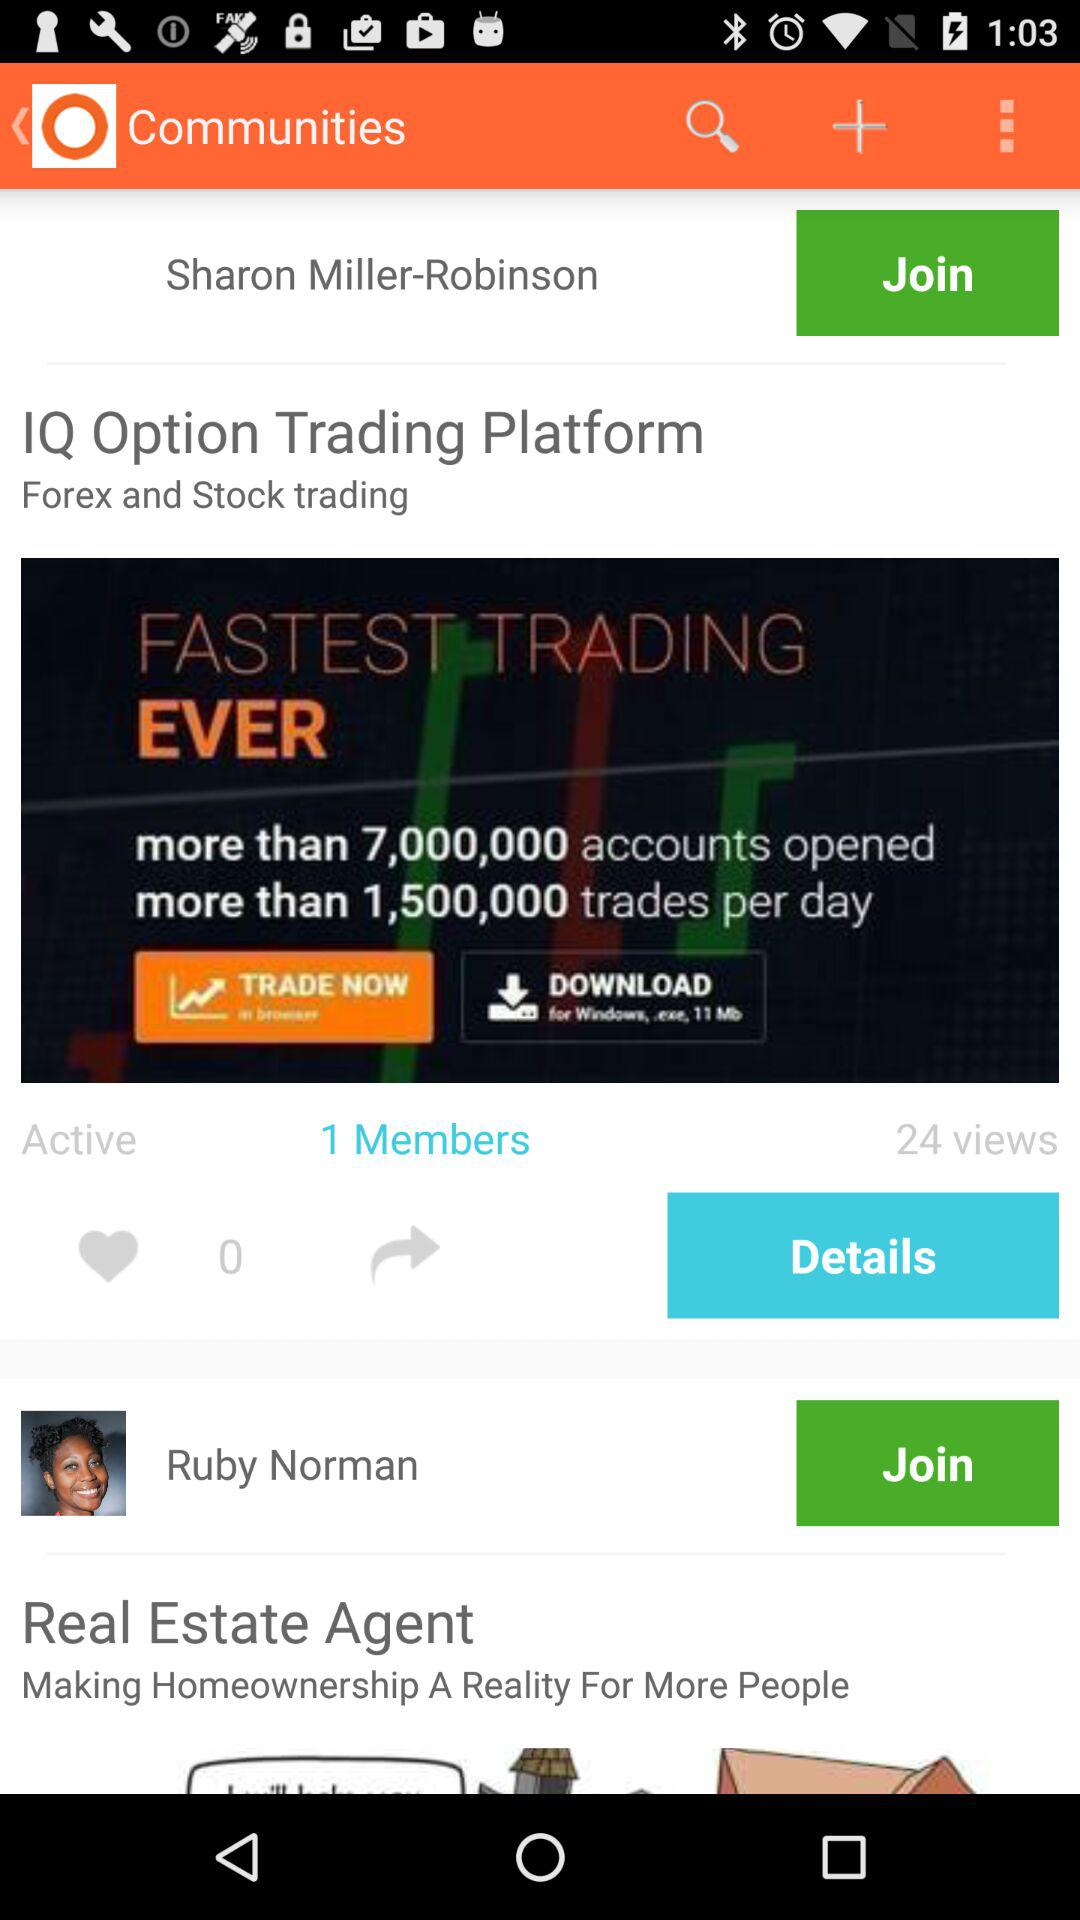How many more members does IQ Option Trading Platform have than Sharon Miller-Robinson?
Answer the question using a single word or phrase. 1 